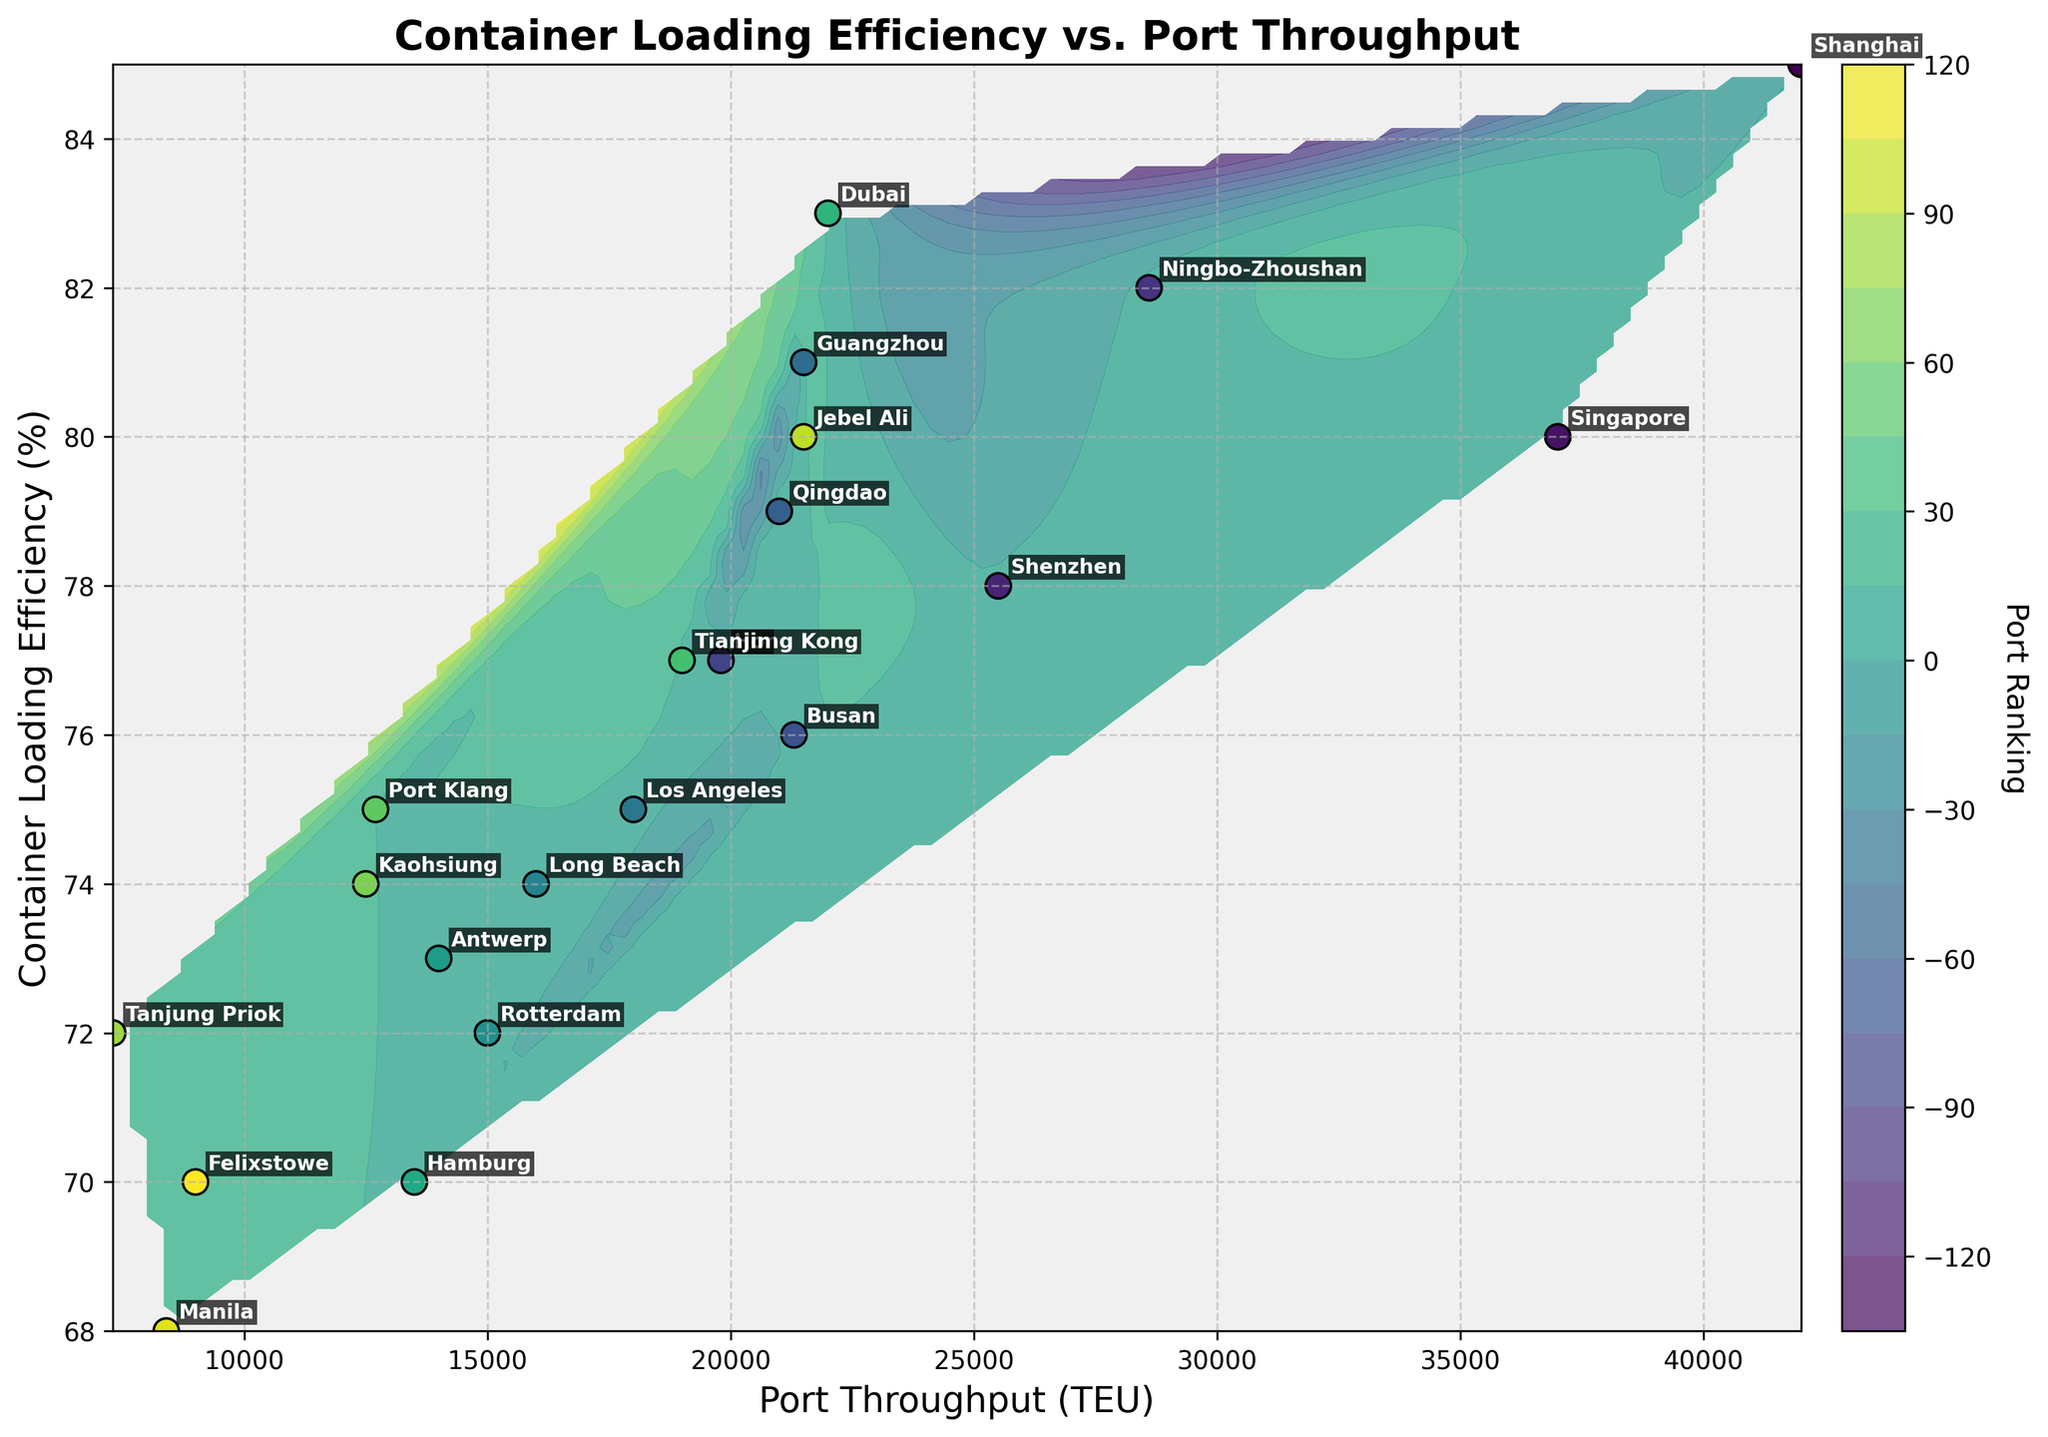What is the title of the plot? The title of the plot appears at the top and provides a summary of the entire figure. By looking at the top of the figure, you can see the title: "Container Loading Efficiency vs. Port Throughput".
Answer: Container Loading Efficiency vs. Port Throughput What does the color of the dots represent? The colors of the dots depict port rankings and are shown via a color gradient from the color bar. The legend indicates this via "Port Ranking".
Answer: Port Ranking How many data points are plotted on the graph? Each city mentioned in the data represents a data point on the graph. By counting the names visible, the total number can be determined. There are 21 cities listed.
Answer: 21 Which port has the highest container loading efficiency? To answer this, find the port associated with the highest value on the vertical axis representing "Container Loading Efficiency".
Answer: Shanghai Which port has the lowest throughput? Look for the port positioned at the lowest value on the horizontal axis, representing "Port Throughput". The port corresponding to this value is Tanjung Priok.
Answer: Tanjung Priok What's the average container loading efficiency of ports with throughput over 20000 TEU? Identify the ports with throughput over 20000 TEU (Shanghai, Singapore, Ningbo-Zhoushan, Qingdao, Guangzhou, Dubai, Jebel Ali) and calculate their average efficiency. (85+80+82+79+81+83+80)/7 = 570/7
Answer: 81.4 Compare the port throughput of Los Angeles and Long Beach. Which has a higher value? By locating both ports on the horizontal axis representing "Port Throughput", it's clear that Los Angeles has a higher throughput than Long Beach.
Answer: Los Angeles Are there more ports with efficiency above 80% or below 70%? Identify ports with container loading efficiency above 80% (Shanghai, Ningbo-Zhoushan, Guangzhou, Dubai) and count ports with efficiency below 70% (Hamburg, Manila, Felixstowe). There are more ports above 80% than below 70%.
Answer: Above 80% What is the general trend shown between port throughput and container loading efficiency? Observing the scatter and contour lines, there's no stringent linear trend, but it suggests that ports with higher throughput tend to maintain high efficiency.
Answer: Higher throughput, high efficiency Which port appears closer to the contour line indicating lower efficiency regions? By closely examining the contour lines and the positioning, Tanjung Priok appears within regions indicative of lower efficiencies.
Answer: Tanjung Priok 